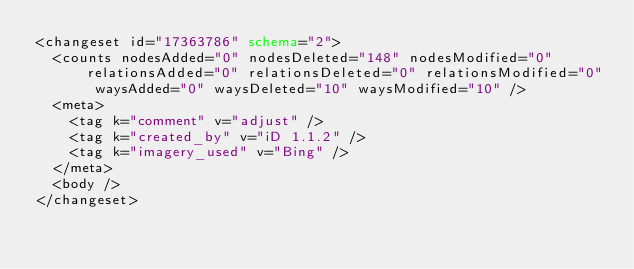<code> <loc_0><loc_0><loc_500><loc_500><_XML_><changeset id="17363786" schema="2">
  <counts nodesAdded="0" nodesDeleted="148" nodesModified="0" relationsAdded="0" relationsDeleted="0" relationsModified="0" waysAdded="0" waysDeleted="10" waysModified="10" />
  <meta>
    <tag k="comment" v="adjust" />
    <tag k="created_by" v="iD 1.1.2" />
    <tag k="imagery_used" v="Bing" />
  </meta>
  <body />
</changeset>
</code> 